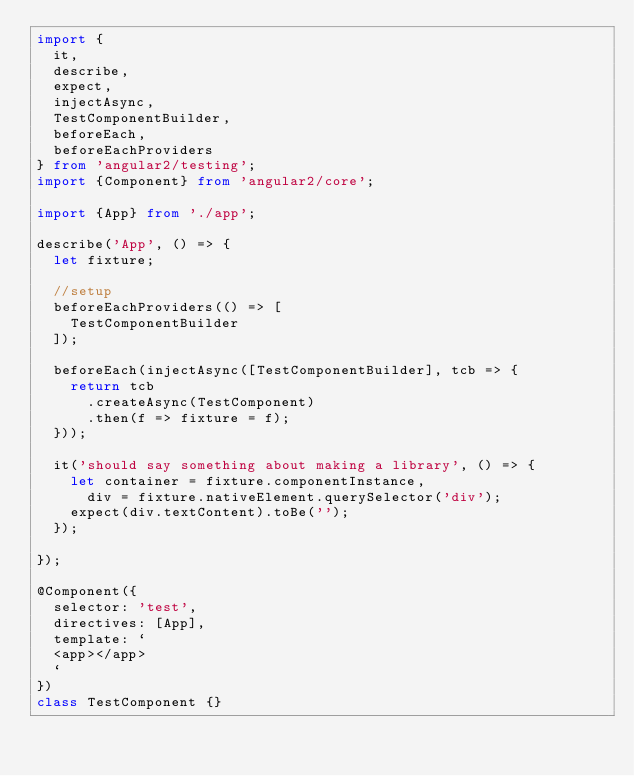Convert code to text. <code><loc_0><loc_0><loc_500><loc_500><_TypeScript_>import {
  it,
  describe,
  expect,
  injectAsync,
  TestComponentBuilder,
  beforeEach,
  beforeEachProviders
} from 'angular2/testing';
import {Component} from 'angular2/core';

import {App} from './app';

describe('App', () => {
  let fixture;
  
  //setup
  beforeEachProviders(() => [
    TestComponentBuilder
  ]);

  beforeEach(injectAsync([TestComponentBuilder], tcb => {
    return tcb
      .createAsync(TestComponent)
      .then(f => fixture = f);
  }));

  it('should say something about making a library', () => {
    let container = fixture.componentInstance,
      div = fixture.nativeElement.querySelector('div');
    expect(div.textContent).toBe('');
  });

});

@Component({
  selector: 'test',
  directives: [App],
  template: `
  <app></app>
  `
})
class TestComponent {}
</code> 